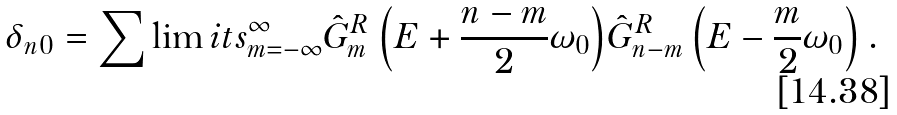<formula> <loc_0><loc_0><loc_500><loc_500>\delta _ { n 0 } = \sum \lim i t s _ { m = - \infty } ^ { \infty } { \hat { G } _ { m } ^ { R } \left ( { E + \frac { n - m } { 2 } \omega _ { 0 } } \right ) } \hat { G } _ { n - m } ^ { R } \left ( { E - \frac { m } { 2 } \omega _ { 0 } } \right ) .</formula> 